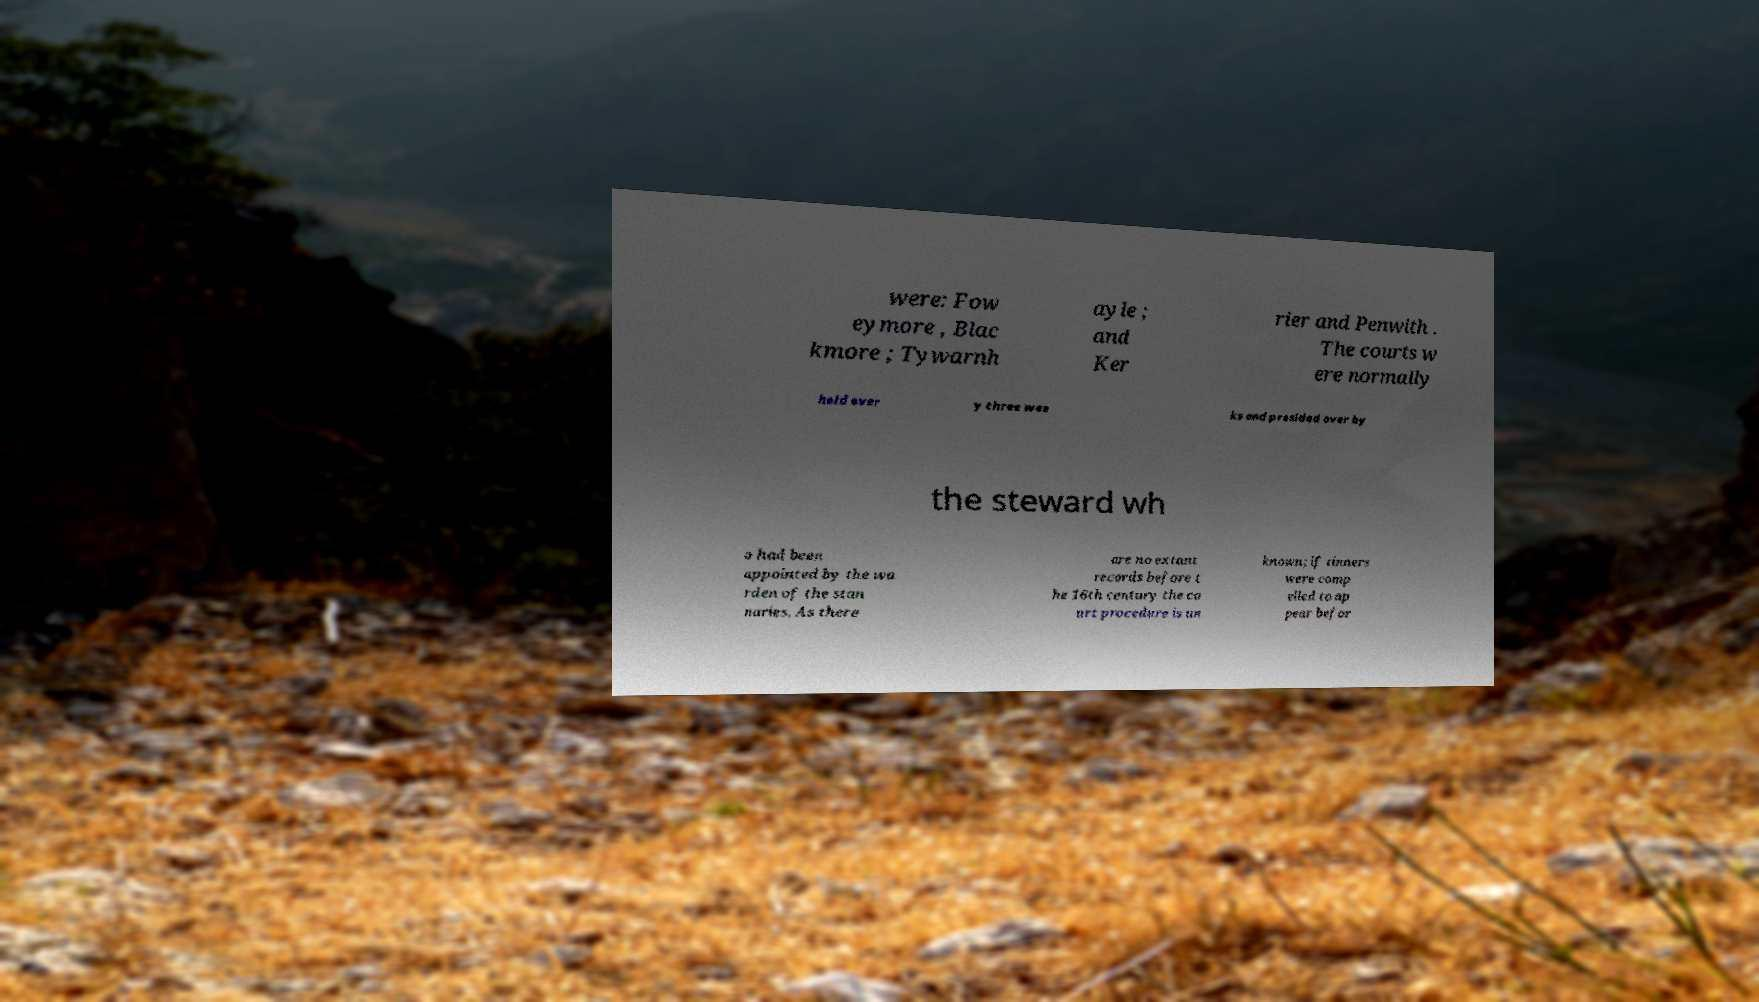I need the written content from this picture converted into text. Can you do that? were: Fow eymore , Blac kmore ; Tywarnh ayle ; and Ker rier and Penwith . The courts w ere normally held ever y three wee ks and presided over by the steward wh o had been appointed by the wa rden of the stan naries. As there are no extant records before t he 16th century the co urt procedure is un known; if tinners were comp elled to ap pear befor 